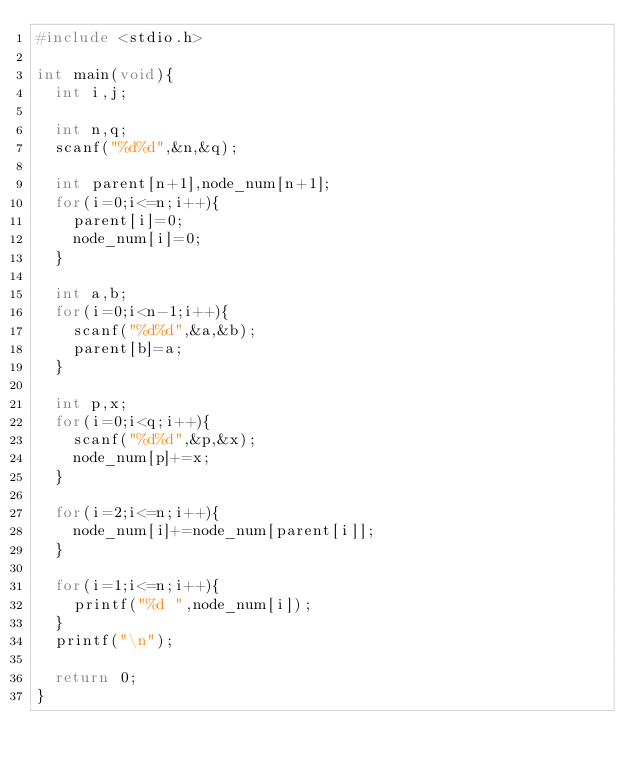Convert code to text. <code><loc_0><loc_0><loc_500><loc_500><_C_>#include <stdio.h>

int main(void){
  int i,j;

  int n,q;
  scanf("%d%d",&n,&q);

  int parent[n+1],node_num[n+1];
  for(i=0;i<=n;i++){
    parent[i]=0;
    node_num[i]=0;
  }

  int a,b;
  for(i=0;i<n-1;i++){
    scanf("%d%d",&a,&b);
    parent[b]=a;
  }

  int p,x;
  for(i=0;i<q;i++){
    scanf("%d%d",&p,&x);
    node_num[p]+=x;
  }

  for(i=2;i<=n;i++){
    node_num[i]+=node_num[parent[i]];
  }

  for(i=1;i<=n;i++){
    printf("%d ",node_num[i]);
  }
  printf("\n");

  return 0;
}
</code> 